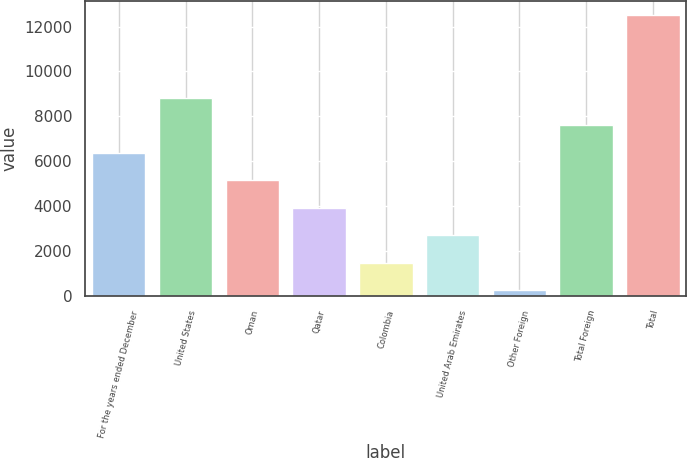<chart> <loc_0><loc_0><loc_500><loc_500><bar_chart><fcel>For the years ended December<fcel>United States<fcel>Oman<fcel>Qatar<fcel>Colombia<fcel>United Arab Emirates<fcel>Other Foreign<fcel>Total Foreign<fcel>Total<nl><fcel>6388.5<fcel>8836.3<fcel>5164.6<fcel>3940.7<fcel>1492.9<fcel>2716.8<fcel>269<fcel>7612.4<fcel>12508<nl></chart> 